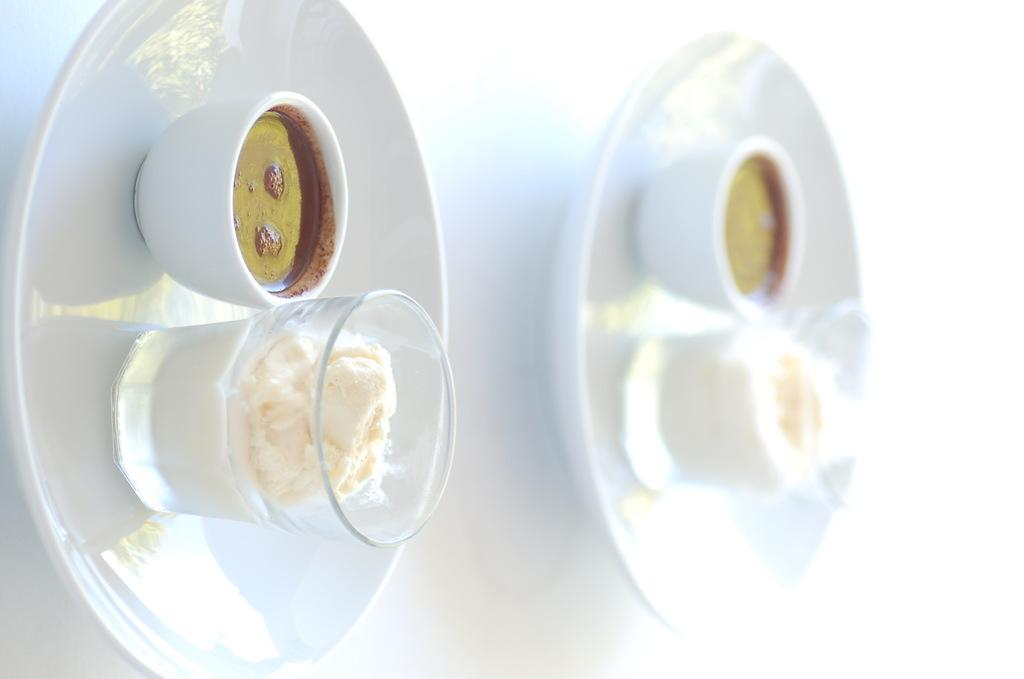How many plates are visible in the image? There are two plates in the image. What is on each plate? Each plate has a bowl on it, and each bowl contains some food. What else is on each plate? Each plate also has a glass on it. What is in each glass? Each glass contains an ice cream. What type of beast can be seen grazing on the ground in the image? There is no beast or ground present in the image; it features two plates with bowls, food, glasses, and ice creams. 